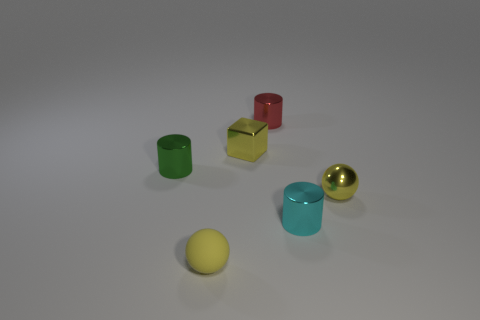Add 4 large purple metal things. How many objects exist? 10 Subtract 2 yellow balls. How many objects are left? 4 Subtract all cubes. How many objects are left? 5 Subtract all tiny spheres. Subtract all yellow things. How many objects are left? 1 Add 1 tiny red metal cylinders. How many tiny red metal cylinders are left? 2 Add 2 matte balls. How many matte balls exist? 3 